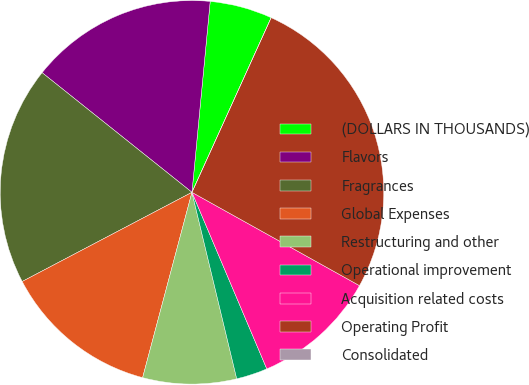Convert chart to OTSL. <chart><loc_0><loc_0><loc_500><loc_500><pie_chart><fcel>(DOLLARS IN THOUSANDS)<fcel>Flavors<fcel>Fragrances<fcel>Global Expenses<fcel>Restructuring and other<fcel>Operational improvement<fcel>Acquisition related costs<fcel>Operating Profit<fcel>Consolidated<nl><fcel>5.26%<fcel>15.79%<fcel>18.42%<fcel>13.16%<fcel>7.89%<fcel>2.63%<fcel>10.53%<fcel>26.31%<fcel>0.0%<nl></chart> 